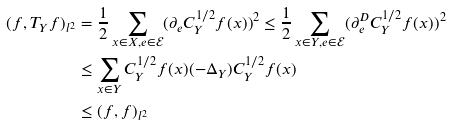<formula> <loc_0><loc_0><loc_500><loc_500>( f , T _ { Y } f ) _ { l ^ { 2 } } & = \frac { 1 } { 2 } \sum _ { x \in X , e \in \mathcal { E } } ( \partial _ { e } C _ { Y } ^ { 1 / 2 } f ( x ) ) ^ { 2 } \leq \frac { 1 } { 2 } \sum _ { x \in Y , e \in \mathcal { E } } ( \partial _ { e } ^ { D } C _ { Y } ^ { 1 / 2 } f ( x ) ) ^ { 2 } \\ & \leq \sum _ { x \in Y } C _ { Y } ^ { 1 / 2 } f ( x ) ( - \Delta _ { Y } ) C _ { Y } ^ { 1 / 2 } f ( x ) \\ & \leq ( f , f ) _ { l ^ { 2 } }</formula> 